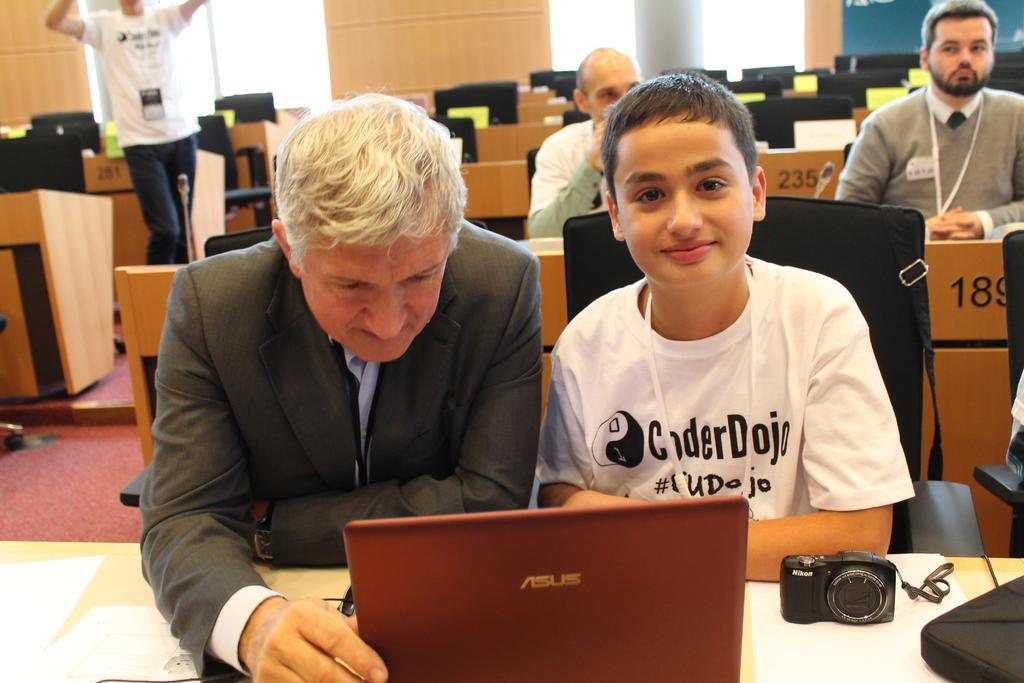How would you summarize this image in a sentence or two? in a room there are tables and black chairs. on the front table there is a red color laptop, camera and papers. in front of that there are 2 people sitting. the person at the left is wearing a suit. the person at the right is wearing white t shirt. behind them there are 2 more people sitting. at the left a person is standing wearing white t shirt and jeans. at the back there are pillars. 